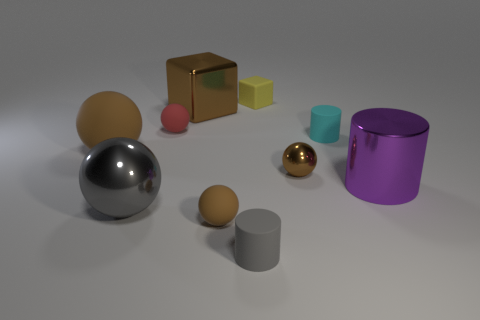There is a small thing that is the same color as the big shiny sphere; what shape is it?
Ensure brevity in your answer.  Cylinder. Does the yellow object have the same size as the cyan matte thing?
Your answer should be compact. Yes. What is the color of the ball that is behind the tiny cyan cylinder?
Offer a very short reply. Red. There is a cyan cylinder that is the same material as the small block; what is its size?
Give a very brief answer. Small. Does the red sphere have the same size as the metallic object in front of the purple thing?
Your answer should be very brief. No. What is the big object on the right side of the small cyan matte object made of?
Provide a succinct answer. Metal. What number of small shiny things are to the right of the brown object on the right side of the small rubber block?
Your answer should be compact. 0. There is a metal object right of the cyan matte thing; is it the same size as the brown thing to the left of the big metallic sphere?
Your response must be concise. Yes. There is a big brown thing that is on the right side of the brown ball to the left of the red object; what shape is it?
Make the answer very short. Cube. How many brown metallic balls are the same size as the cyan cylinder?
Offer a terse response. 1. 